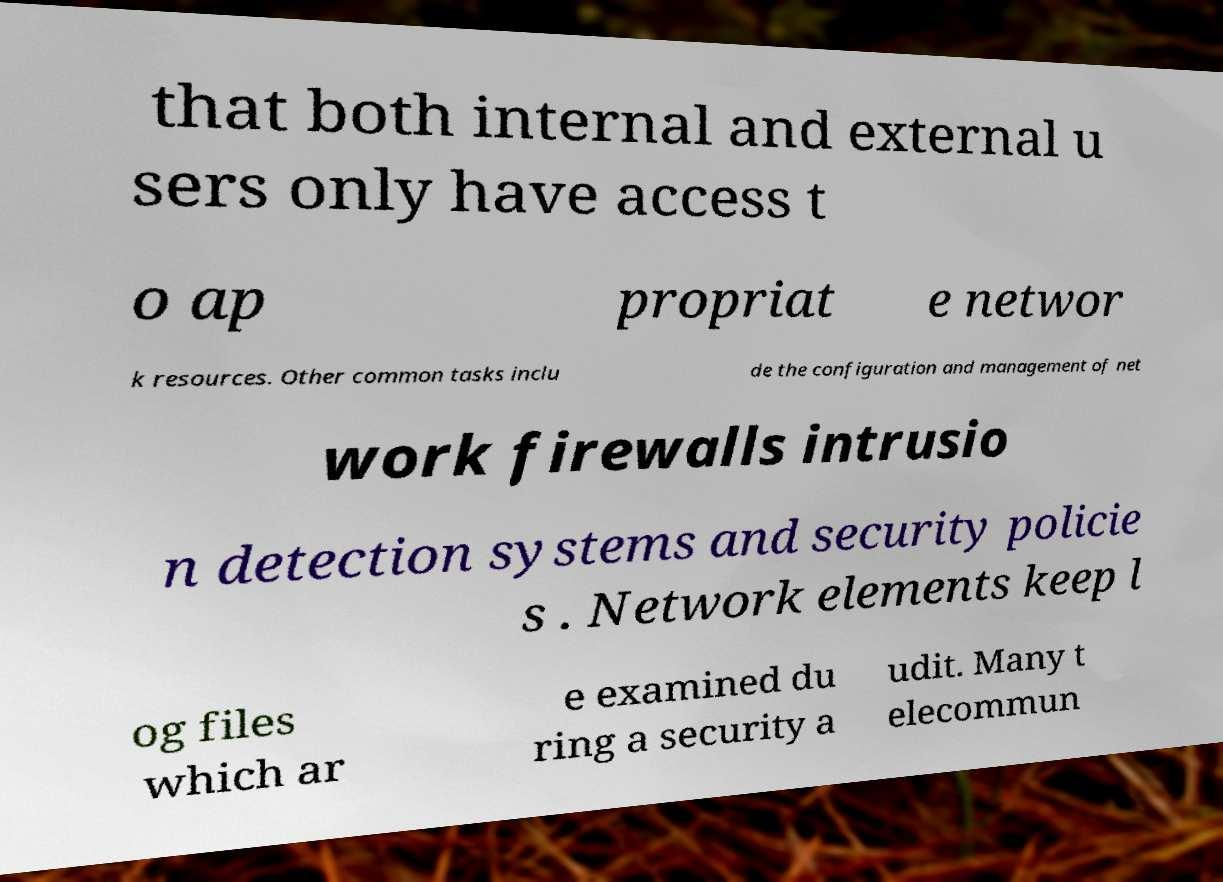I need the written content from this picture converted into text. Can you do that? that both internal and external u sers only have access t o ap propriat e networ k resources. Other common tasks inclu de the configuration and management of net work firewalls intrusio n detection systems and security policie s . Network elements keep l og files which ar e examined du ring a security a udit. Many t elecommun 